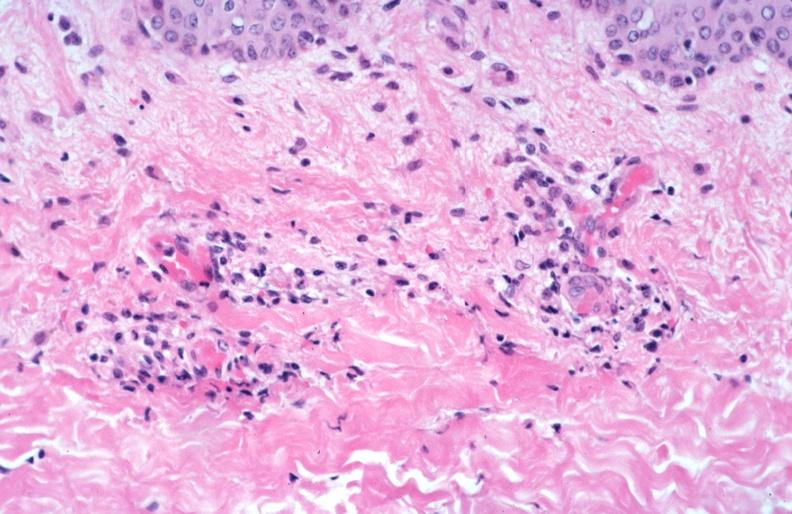where is this?
Answer the question using a single word or phrase. Skin 